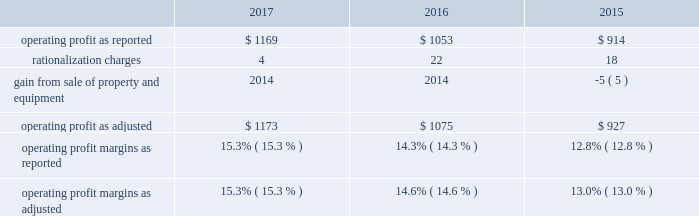Affected by lower sales volume of cabinets , the divestiture of our arrow and moores businesses , and an unfavorable sales mix of international plumbing products , which , in aggregate , decreased sales by approximately two percent compared to 2016 .
Net sales for 2016 were positively affected by increased sales volume of plumbing products , paints and other coating products and builders' hardware , which , in aggregate , increased sales by approximately five percent compared to 2015 .
Net sales for 2016 were also positively affected by favorable sales mix of cabinets and windows , and net selling price increases of north american windows and north american and international plumbing products , which , in aggregate , increased sales approximately one percent .
Net sales for 2016 were negatively affected by lower sales volume of cabinets and lower net selling prices of paints and other coating products , which , in aggregate , decreased sales by approximately two percent .
Net sales for 2015 were positively affected by increased sales volume of plumbing products , paints and other coating products , windows and builders' hardware .
Net sales for 2015 were also positively affected by net selling price increases of plumbing products , cabinets and windows , as well as sales mix of north american cabinets and windows .
Net sales for 2015 were negatively affected by lower sales volume of cabinets and lower net selling prices of paints and other coating products .
Our gross profit margins were 34.2 percent , 33.4 percent and 31.5 percent in 2017 , 2016 and 2015 , respectively .
The 2017 and 2016 gross profit margins were positively impacted by increased sales volume , a more favorable relationship between net selling prices and commodity costs , and cost savings initiatives .
2016 gross profit margins were negatively impacted by an increase in warranty costs resulting from a change in our estimate of expected future warranty claim costs .
Selling , general and administrative expenses as a percent of sales were 18.9 percent in 2017 compared with 19.1 percent in 2016 and 18.7 percent in 2015 .
Selling , general and administrative expenses as a percent of sales in 2017 reflect increased sales and the effect of cost containment measures , partially offset by an increase in strategic growth investments , stock-based compensation , health insurance costs and trade show costs .
Selling , general and administrative expenses as a percent of sales in 2016 reflect strategic growth investments , erp system implementation costs and higher insurance costs .
The table reconciles reported operating profit to operating profit , as adjusted to exclude certain items , dollars in millions: .
Operating profit margins in 2017 and 2016 were positively affected by increased sales volume , cost savings initiatives , and a more favorable relationship between net selling prices and commodity costs .
Operating profit margin in 2017 was negatively impacted by an increase in strategic growth investments and certain other expenses , including stock-based compensation , health insurance costs , trade show costs and increased head count .
Operating profit margin in 2016 was negatively impacted by an increase in warranty costs by a business in our windows and other specialty products segment and an increase in strategic growth investments , as well as erp system implementation costs and higher insurance costs .
.......................................................... .
.................................................................. .
..................................... .
........................................................ .
............................................ .
............................................. .
What was the difference in operating profit margins as adjusted from 2015 to 2016? 
Computations: (14.6% - 13.0%)
Answer: 0.016. Affected by lower sales volume of cabinets , the divestiture of our arrow and moores businesses , and an unfavorable sales mix of international plumbing products , which , in aggregate , decreased sales by approximately two percent compared to 2016 .
Net sales for 2016 were positively affected by increased sales volume of plumbing products , paints and other coating products and builders' hardware , which , in aggregate , increased sales by approximately five percent compared to 2015 .
Net sales for 2016 were also positively affected by favorable sales mix of cabinets and windows , and net selling price increases of north american windows and north american and international plumbing products , which , in aggregate , increased sales approximately one percent .
Net sales for 2016 were negatively affected by lower sales volume of cabinets and lower net selling prices of paints and other coating products , which , in aggregate , decreased sales by approximately two percent .
Net sales for 2015 were positively affected by increased sales volume of plumbing products , paints and other coating products , windows and builders' hardware .
Net sales for 2015 were also positively affected by net selling price increases of plumbing products , cabinets and windows , as well as sales mix of north american cabinets and windows .
Net sales for 2015 were negatively affected by lower sales volume of cabinets and lower net selling prices of paints and other coating products .
Our gross profit margins were 34.2 percent , 33.4 percent and 31.5 percent in 2017 , 2016 and 2015 , respectively .
The 2017 and 2016 gross profit margins were positively impacted by increased sales volume , a more favorable relationship between net selling prices and commodity costs , and cost savings initiatives .
2016 gross profit margins were negatively impacted by an increase in warranty costs resulting from a change in our estimate of expected future warranty claim costs .
Selling , general and administrative expenses as a percent of sales were 18.9 percent in 2017 compared with 19.1 percent in 2016 and 18.7 percent in 2015 .
Selling , general and administrative expenses as a percent of sales in 2017 reflect increased sales and the effect of cost containment measures , partially offset by an increase in strategic growth investments , stock-based compensation , health insurance costs and trade show costs .
Selling , general and administrative expenses as a percent of sales in 2016 reflect strategic growth investments , erp system implementation costs and higher insurance costs .
The table reconciles reported operating profit to operating profit , as adjusted to exclude certain items , dollars in millions: .
Operating profit margins in 2017 and 2016 were positively affected by increased sales volume , cost savings initiatives , and a more favorable relationship between net selling prices and commodity costs .
Operating profit margin in 2017 was negatively impacted by an increase in strategic growth investments and certain other expenses , including stock-based compensation , health insurance costs , trade show costs and increased head count .
Operating profit margin in 2016 was negatively impacted by an increase in warranty costs by a business in our windows and other specialty products segment and an increase in strategic growth investments , as well as erp system implementation costs and higher insurance costs .
.......................................................... .
.................................................................. .
..................................... .
........................................................ .
............................................ .
............................................. .
What was the difference in operating profit margins as adjusted from 2016 to 2017? 
Computations: (15.3% - 14.6%)
Answer: 0.007. Affected by lower sales volume of cabinets , the divestiture of our arrow and moores businesses , and an unfavorable sales mix of international plumbing products , which , in aggregate , decreased sales by approximately two percent compared to 2016 .
Net sales for 2016 were positively affected by increased sales volume of plumbing products , paints and other coating products and builders' hardware , which , in aggregate , increased sales by approximately five percent compared to 2015 .
Net sales for 2016 were also positively affected by favorable sales mix of cabinets and windows , and net selling price increases of north american windows and north american and international plumbing products , which , in aggregate , increased sales approximately one percent .
Net sales for 2016 were negatively affected by lower sales volume of cabinets and lower net selling prices of paints and other coating products , which , in aggregate , decreased sales by approximately two percent .
Net sales for 2015 were positively affected by increased sales volume of plumbing products , paints and other coating products , windows and builders' hardware .
Net sales for 2015 were also positively affected by net selling price increases of plumbing products , cabinets and windows , as well as sales mix of north american cabinets and windows .
Net sales for 2015 were negatively affected by lower sales volume of cabinets and lower net selling prices of paints and other coating products .
Our gross profit margins were 34.2 percent , 33.4 percent and 31.5 percent in 2017 , 2016 and 2015 , respectively .
The 2017 and 2016 gross profit margins were positively impacted by increased sales volume , a more favorable relationship between net selling prices and commodity costs , and cost savings initiatives .
2016 gross profit margins were negatively impacted by an increase in warranty costs resulting from a change in our estimate of expected future warranty claim costs .
Selling , general and administrative expenses as a percent of sales were 18.9 percent in 2017 compared with 19.1 percent in 2016 and 18.7 percent in 2015 .
Selling , general and administrative expenses as a percent of sales in 2017 reflect increased sales and the effect of cost containment measures , partially offset by an increase in strategic growth investments , stock-based compensation , health insurance costs and trade show costs .
Selling , general and administrative expenses as a percent of sales in 2016 reflect strategic growth investments , erp system implementation costs and higher insurance costs .
The table reconciles reported operating profit to operating profit , as adjusted to exclude certain items , dollars in millions: .
Operating profit margins in 2017 and 2016 were positively affected by increased sales volume , cost savings initiatives , and a more favorable relationship between net selling prices and commodity costs .
Operating profit margin in 2017 was negatively impacted by an increase in strategic growth investments and certain other expenses , including stock-based compensation , health insurance costs , trade show costs and increased head count .
Operating profit margin in 2016 was negatively impacted by an increase in warranty costs by a business in our windows and other specialty products segment and an increase in strategic growth investments , as well as erp system implementation costs and higher insurance costs .
.......................................................... .
.................................................................. .
..................................... .
........................................................ .
............................................ .
............................................. .
What was the percentage change in the gross profit margins from 2016 to 2017? 
Rationale: the gross profit margins from 2016 to 2017 increased by 2.4%
Computations: ((34.2 - 33.4) / 33.4)
Answer: 0.02395. 